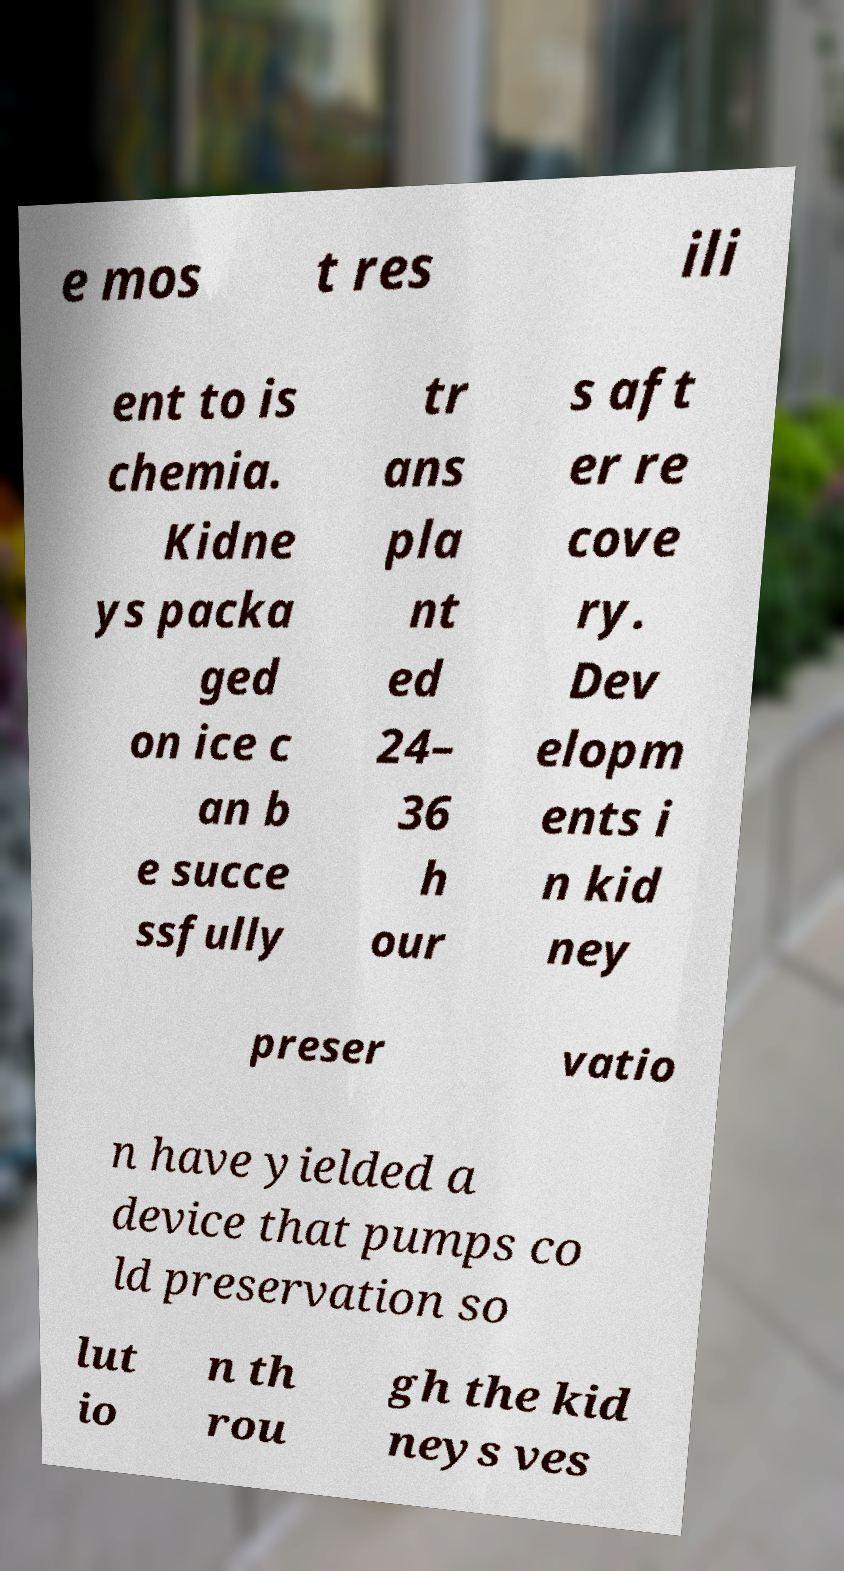Please identify and transcribe the text found in this image. e mos t res ili ent to is chemia. Kidne ys packa ged on ice c an b e succe ssfully tr ans pla nt ed 24– 36 h our s aft er re cove ry. Dev elopm ents i n kid ney preser vatio n have yielded a device that pumps co ld preservation so lut io n th rou gh the kid neys ves 